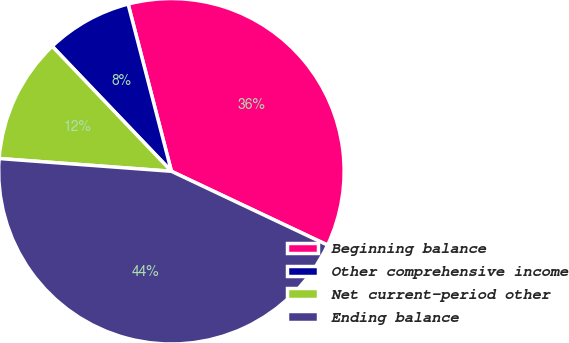Convert chart to OTSL. <chart><loc_0><loc_0><loc_500><loc_500><pie_chart><fcel>Beginning balance<fcel>Other comprehensive income<fcel>Net current-period other<fcel>Ending balance<nl><fcel>36.06%<fcel>8.09%<fcel>11.7%<fcel>44.15%<nl></chart> 